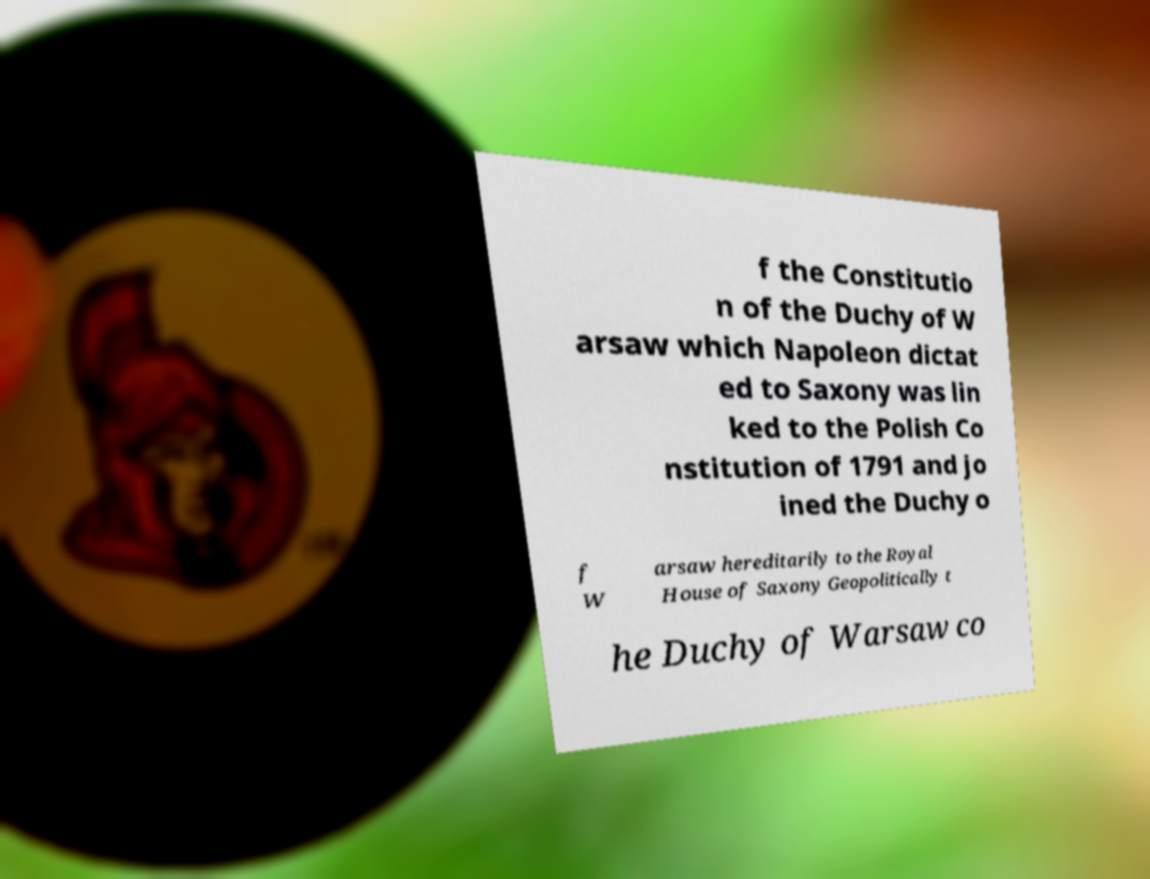Can you read and provide the text displayed in the image?This photo seems to have some interesting text. Can you extract and type it out for me? f the Constitutio n of the Duchy of W arsaw which Napoleon dictat ed to Saxony was lin ked to the Polish Co nstitution of 1791 and jo ined the Duchy o f W arsaw hereditarily to the Royal House of Saxony Geopolitically t he Duchy of Warsaw co 